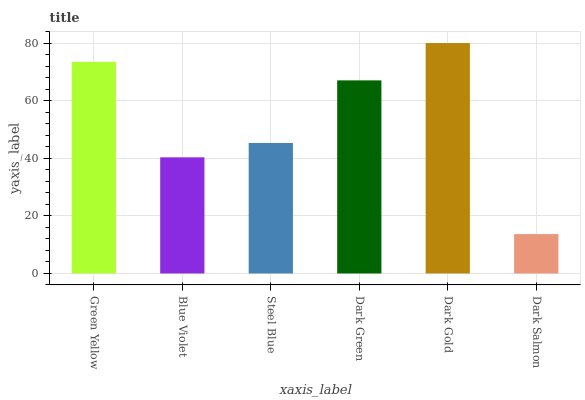Is Dark Salmon the minimum?
Answer yes or no. Yes. Is Dark Gold the maximum?
Answer yes or no. Yes. Is Blue Violet the minimum?
Answer yes or no. No. Is Blue Violet the maximum?
Answer yes or no. No. Is Green Yellow greater than Blue Violet?
Answer yes or no. Yes. Is Blue Violet less than Green Yellow?
Answer yes or no. Yes. Is Blue Violet greater than Green Yellow?
Answer yes or no. No. Is Green Yellow less than Blue Violet?
Answer yes or no. No. Is Dark Green the high median?
Answer yes or no. Yes. Is Steel Blue the low median?
Answer yes or no. Yes. Is Blue Violet the high median?
Answer yes or no. No. Is Dark Green the low median?
Answer yes or no. No. 